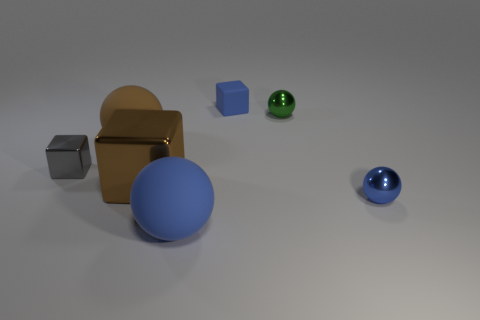Is the number of small gray cubes greater than the number of tiny red cylinders?
Ensure brevity in your answer.  Yes. Is there any other thing that is the same color as the rubber block?
Offer a very short reply. Yes. What shape is the brown thing that is made of the same material as the small green object?
Your response must be concise. Cube. What is the material of the blue sphere on the right side of the blue matte thing that is in front of the green thing?
Your answer should be compact. Metal. Do the blue rubber object that is in front of the tiny gray object and the tiny blue matte thing have the same shape?
Keep it short and to the point. No. Is the number of small gray metallic cubes that are right of the gray shiny block greater than the number of tiny blue balls?
Your answer should be very brief. No. Is there anything else that has the same material as the tiny gray thing?
Your answer should be very brief. Yes. What number of balls are either small blue things or tiny metal things?
Provide a succinct answer. 2. What is the color of the small metal thing that is on the left side of the big ball in front of the gray metallic object?
Your response must be concise. Gray. Is the color of the large metal cube the same as the big matte thing that is on the left side of the big blue matte object?
Provide a short and direct response. Yes. 